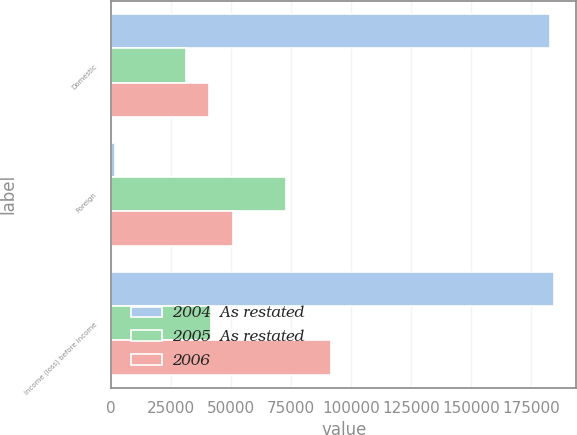<chart> <loc_0><loc_0><loc_500><loc_500><stacked_bar_chart><ecel><fcel>Domestic<fcel>Foreign<fcel>Income (loss) before income<nl><fcel>2004  As restated<fcel>182932<fcel>1550<fcel>184482<nl><fcel>2005  As restated<fcel>31122<fcel>72842<fcel>41720<nl><fcel>2006<fcel>40868<fcel>50876<fcel>91744<nl></chart> 